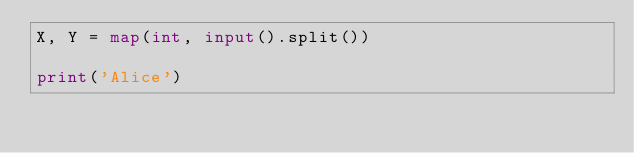Convert code to text. <code><loc_0><loc_0><loc_500><loc_500><_Python_>X, Y = map(int, input().split())
    
print('Alice')</code> 